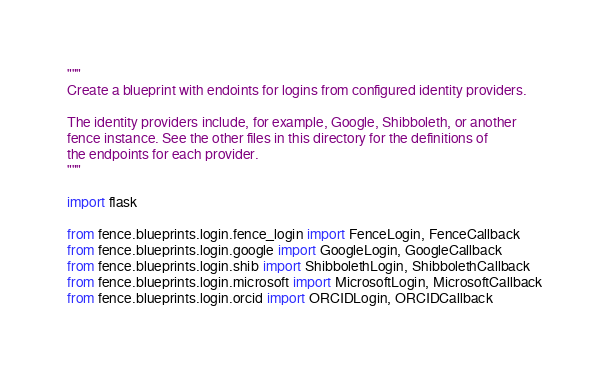Convert code to text. <code><loc_0><loc_0><loc_500><loc_500><_Python_>"""
Create a blueprint with endoints for logins from configured identity providers.

The identity providers include, for example, Google, Shibboleth, or another
fence instance. See the other files in this directory for the definitions of
the endpoints for each provider.
"""

import flask

from fence.blueprints.login.fence_login import FenceLogin, FenceCallback
from fence.blueprints.login.google import GoogleLogin, GoogleCallback
from fence.blueprints.login.shib import ShibbolethLogin, ShibbolethCallback
from fence.blueprints.login.microsoft import MicrosoftLogin, MicrosoftCallback
from fence.blueprints.login.orcid import ORCIDLogin, ORCIDCallback</code> 